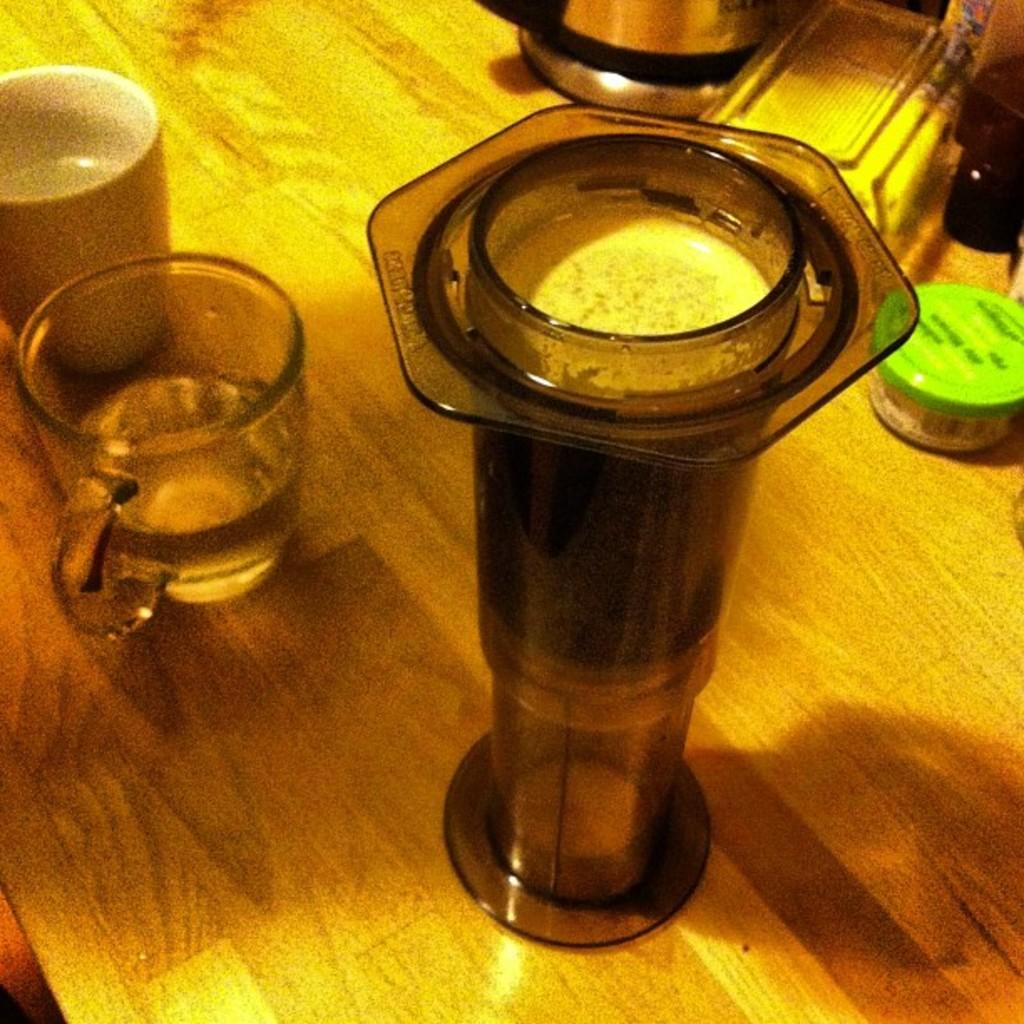What type of containers are visible in the image? There are cups in the image. What can be seen on the wooden surface in the image? There are other objects on the wooden surface in the image. How many ants are crawling on the cups in the image? There are no ants present in the image. What type of bear is sitting next to the cups in the image? There is no bear present in the image. 